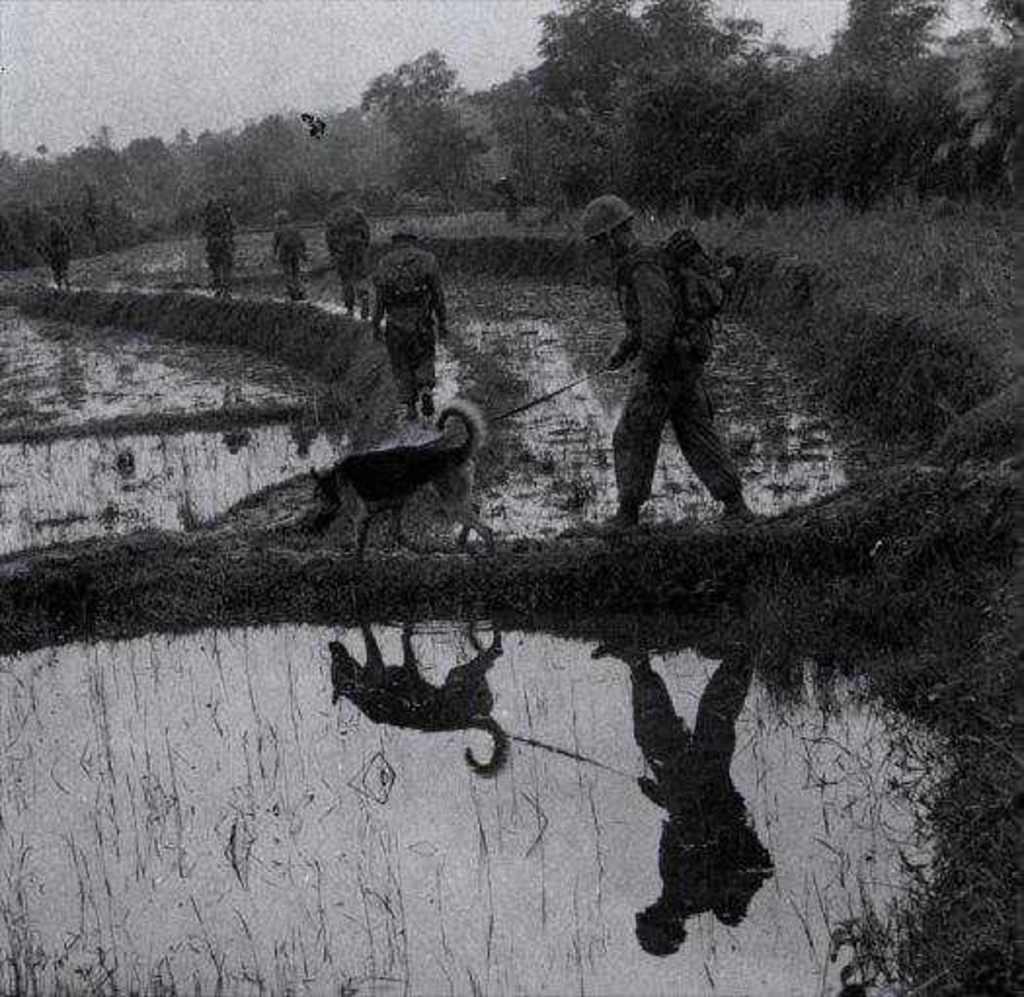Describe this image in one or two sentences. This is a black and white image. In this image I can see the water on the ground. It seems like a crop field. In the middle of the image there is a person walking on the land by holding the belt of a dog. In the background there are some more people walking and there are many trees. At the top of the image I can see the sky. 